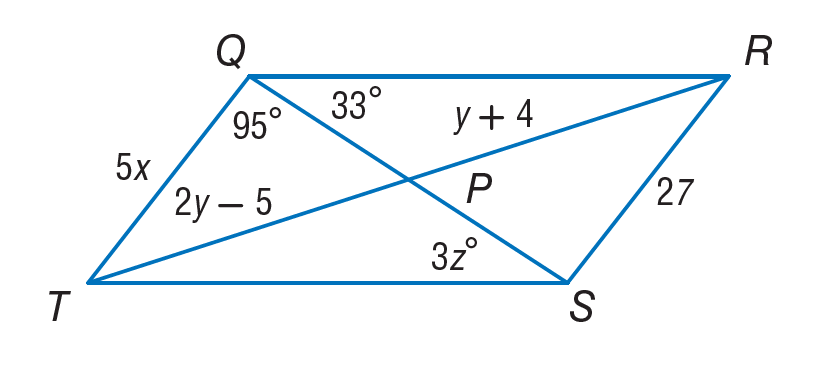Question: If Q R S T is a parallelogram, find x.
Choices:
A. 5.4
B. 9
C. 11
D. 13
Answer with the letter. Answer: A Question: If Q R S T is a parallelogram, find y.
Choices:
A. 5.4
B. 9
C. 11
D. 22
Answer with the letter. Answer: B Question: If Q R S T is a parallelogram. Find z.
Choices:
A. 5.4
B. 7
C. 9
D. 11
Answer with the letter. Answer: D 